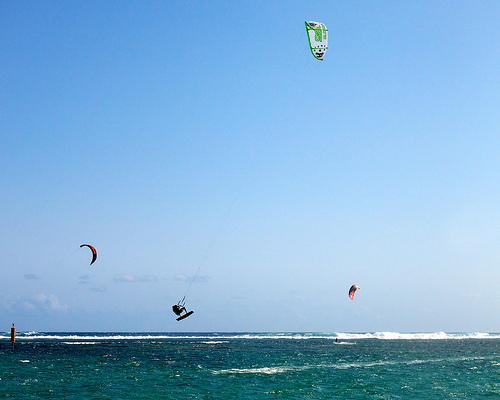Summarize the scene captured in the image in a single sentence. A kite surfer soars above the ocean waves with multiple colorful kites flying high in the clear blue sky. Describe the setting of the image as if narrating a story. Once upon a time, on a sunny day with clear blue skies over a lively ocean, a kite surfer dazzled above the rolling waves with a background of soaring kites. Write a short action-packed description of the image. Kite surfer defies gravity, launching skyward amidst a vibrant display of airborne kites, while ocean waves crash dramatically below. Write a haiku inspired by the image. Boundless ocean's grace. Describe the overall atmosphere of the image in a few words. Adrenaline-filled, serene, and scenic ocean adventure. Describe the image using alliteration. Kite surfer skyward soars, splashing with sublime seascapes, surrounded by scintillating, spirited skylarks. Imagine you're sending a postcard to a friend and describe the image captured in the postcard. Hey there! You won't believe the stunning view here – a daring kite surfer takes to the skies above a breathtaking seascape filled with colorful kites and mesmerizing waves! Mention the striking features of the image in a concise manner. High-flying kite surfer, vibrant kites, dynamic ocean waves, and crystal clear blue skies. Describe the image in the form of a news headline. "Gravity-Defying Kite Surfer Steals the Show in Majestic Seascape Spectacle!" Mention the key visual elements in the image in a poetic manner. Ocean's brilliant blues meet the sky's endless hues, as kites dance on the wind, and a surfer takes flight anew. 